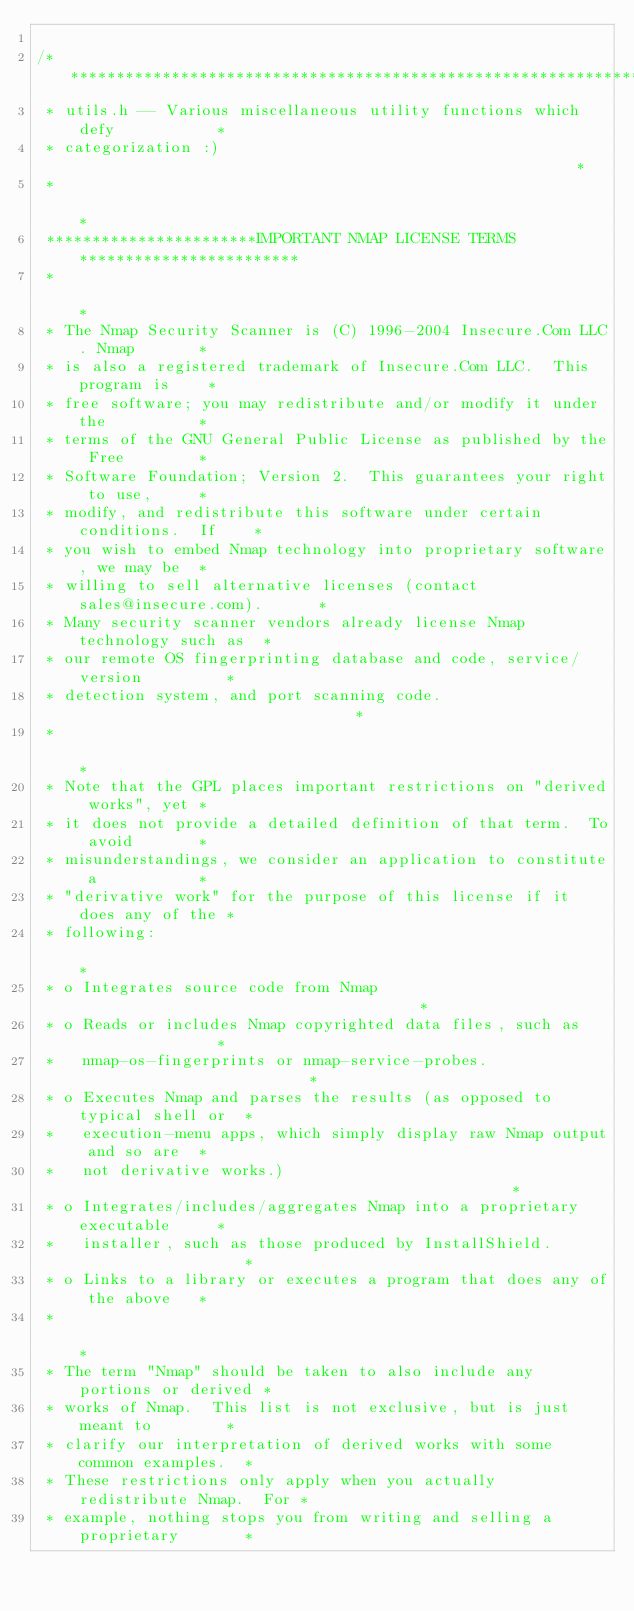<code> <loc_0><loc_0><loc_500><loc_500><_C_>
/***************************************************************************
 * utils.h -- Various miscellaneous utility functions which defy           *
 * categorization :)                                                       *
 *                                                                         *
 ***********************IMPORTANT NMAP LICENSE TERMS************************
 *                                                                         *
 * The Nmap Security Scanner is (C) 1996-2004 Insecure.Com LLC. Nmap       *
 * is also a registered trademark of Insecure.Com LLC.  This program is    *
 * free software; you may redistribute and/or modify it under the          *
 * terms of the GNU General Public License as published by the Free        *
 * Software Foundation; Version 2.  This guarantees your right to use,     *
 * modify, and redistribute this software under certain conditions.  If    *
 * you wish to embed Nmap technology into proprietary software, we may be  *
 * willing to sell alternative licenses (contact sales@insecure.com).      *
 * Many security scanner vendors already license Nmap technology such as  *
 * our remote OS fingerprinting database and code, service/version         *
 * detection system, and port scanning code.                               *
 *                                                                         *
 * Note that the GPL places important restrictions on "derived works", yet *
 * it does not provide a detailed definition of that term.  To avoid       *
 * misunderstandings, we consider an application to constitute a           *
 * "derivative work" for the purpose of this license if it does any of the *
 * following:                                                              *
 * o Integrates source code from Nmap                                      *
 * o Reads or includes Nmap copyrighted data files, such as                *
 *   nmap-os-fingerprints or nmap-service-probes.                          *
 * o Executes Nmap and parses the results (as opposed to typical shell or  *
 *   execution-menu apps, which simply display raw Nmap output and so are  *
 *   not derivative works.)                                                * 
 * o Integrates/includes/aggregates Nmap into a proprietary executable     *
 *   installer, such as those produced by InstallShield.                   *
 * o Links to a library or executes a program that does any of the above   *
 *                                                                         *
 * The term "Nmap" should be taken to also include any portions or derived *
 * works of Nmap.  This list is not exclusive, but is just meant to        *
 * clarify our interpretation of derived works with some common examples.  *
 * These restrictions only apply when you actually redistribute Nmap.  For *
 * example, nothing stops you from writing and selling a proprietary       *</code> 